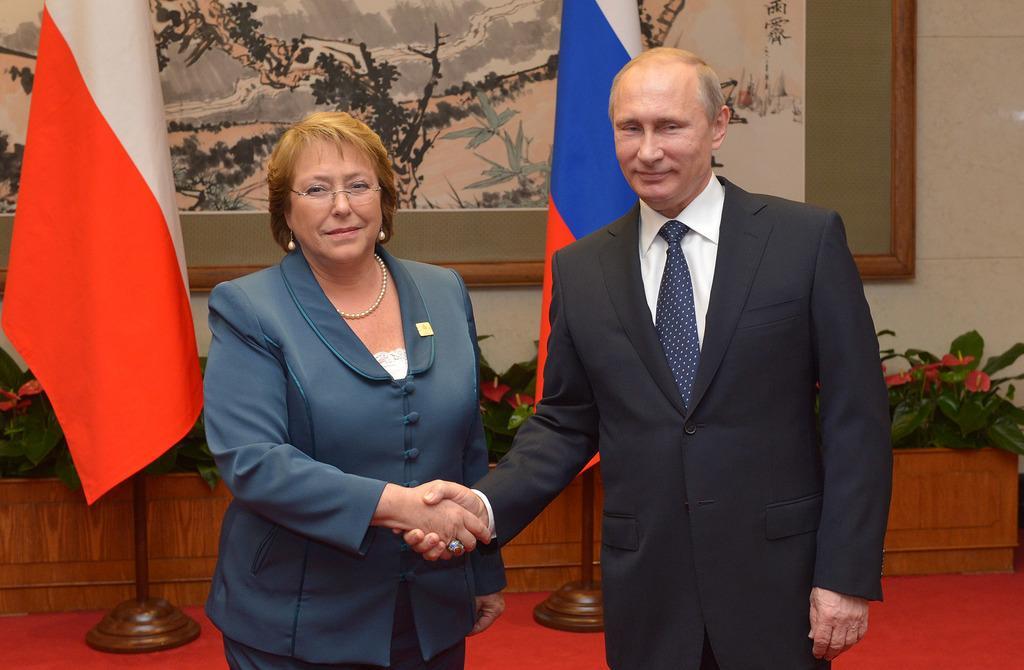Please provide a concise description of this image. In this picture I can see a man and woman shaking their hands and I can see couple of flags on the back and few plants with flowers and I can see a frame on the back. 